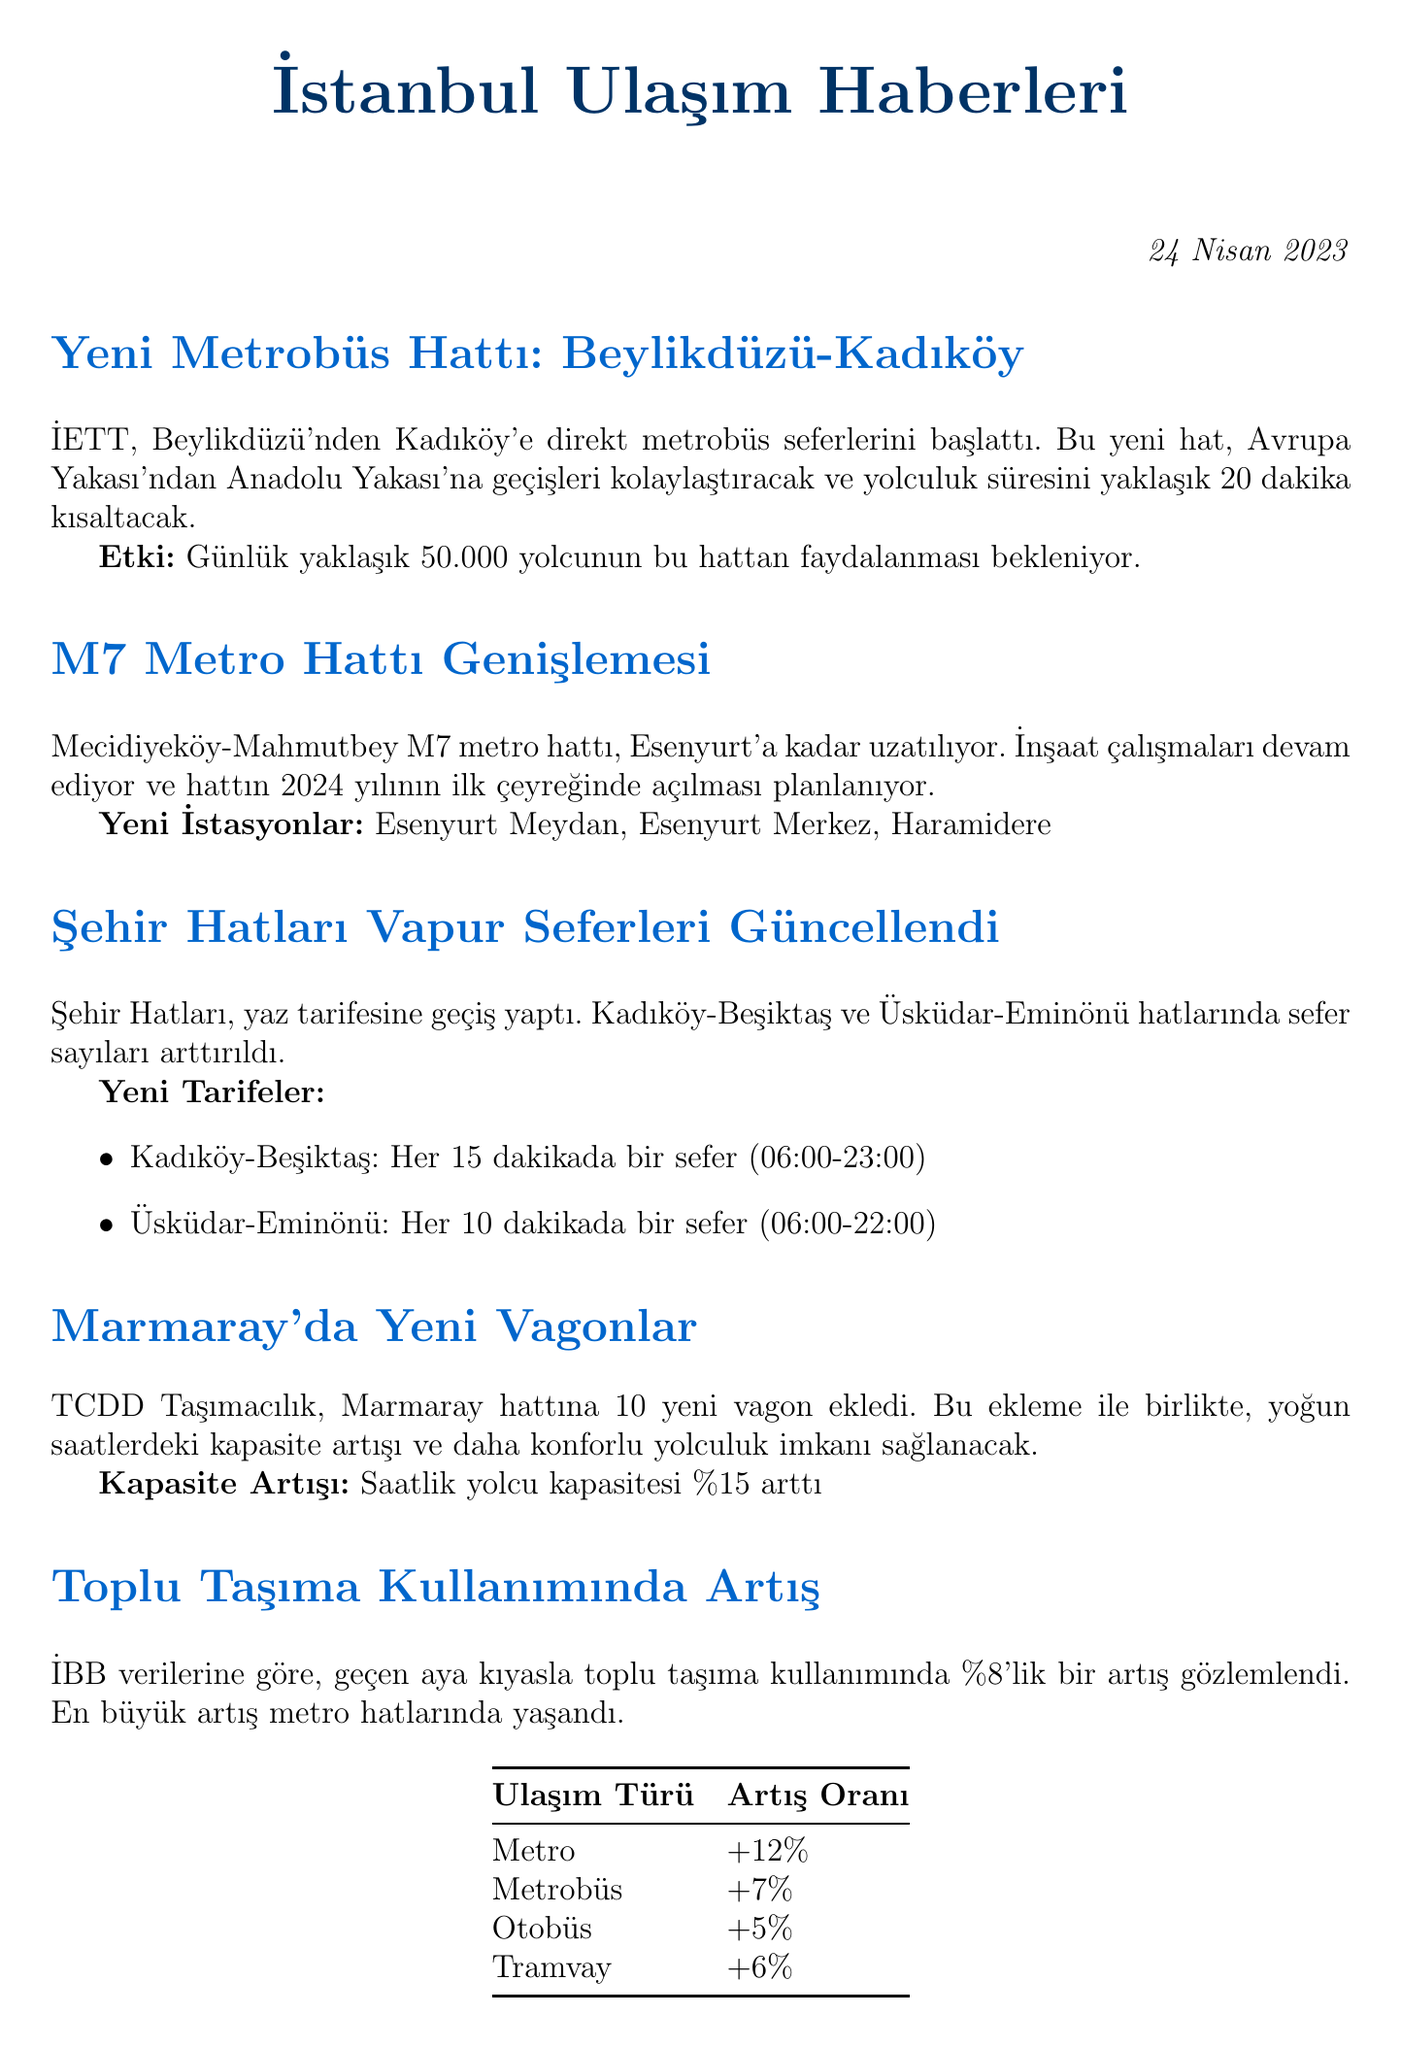What is the issue date of the newsletter? The issue date is clearly stated at the beginning of the document.
Answer: 24 Nisan 2023 What new metro line is being expanded? Information about the metro line expansion is provided in the document.
Answer: M7 Metro Hattı How many new wagons were added to the Marmaray line? The document specifies the number of new wagons added.
Answer: 10 What is the projected opening date for the M7 line extension? The document mentions the planned opening timeframe for the new line.
Answer: 2024 yılının ilk çeyreği How much is the daily passenger expectation for the new Metrobüs route? The expected daily ridership for the new route is indicated in the content.
Answer: 50.000 How much did public transportation usage increase compared to the previous month? The percentage increase in public transportation usage is highlighted in the document.
Answer: %8 What are the two ferry routes with increased service frequency? The document lists the ferry routes affected by schedule changes.
Answer: Kadıköy-Beşiktaş, Üsküdar-Eminönü What percentage increase in metro usage was recorded? The document presents specific percentage increases for each mode of transport, including metro.
Answer: +12% What type of document is this? The structure and content indicate the purpose of the document.
Answer: Newsletter 